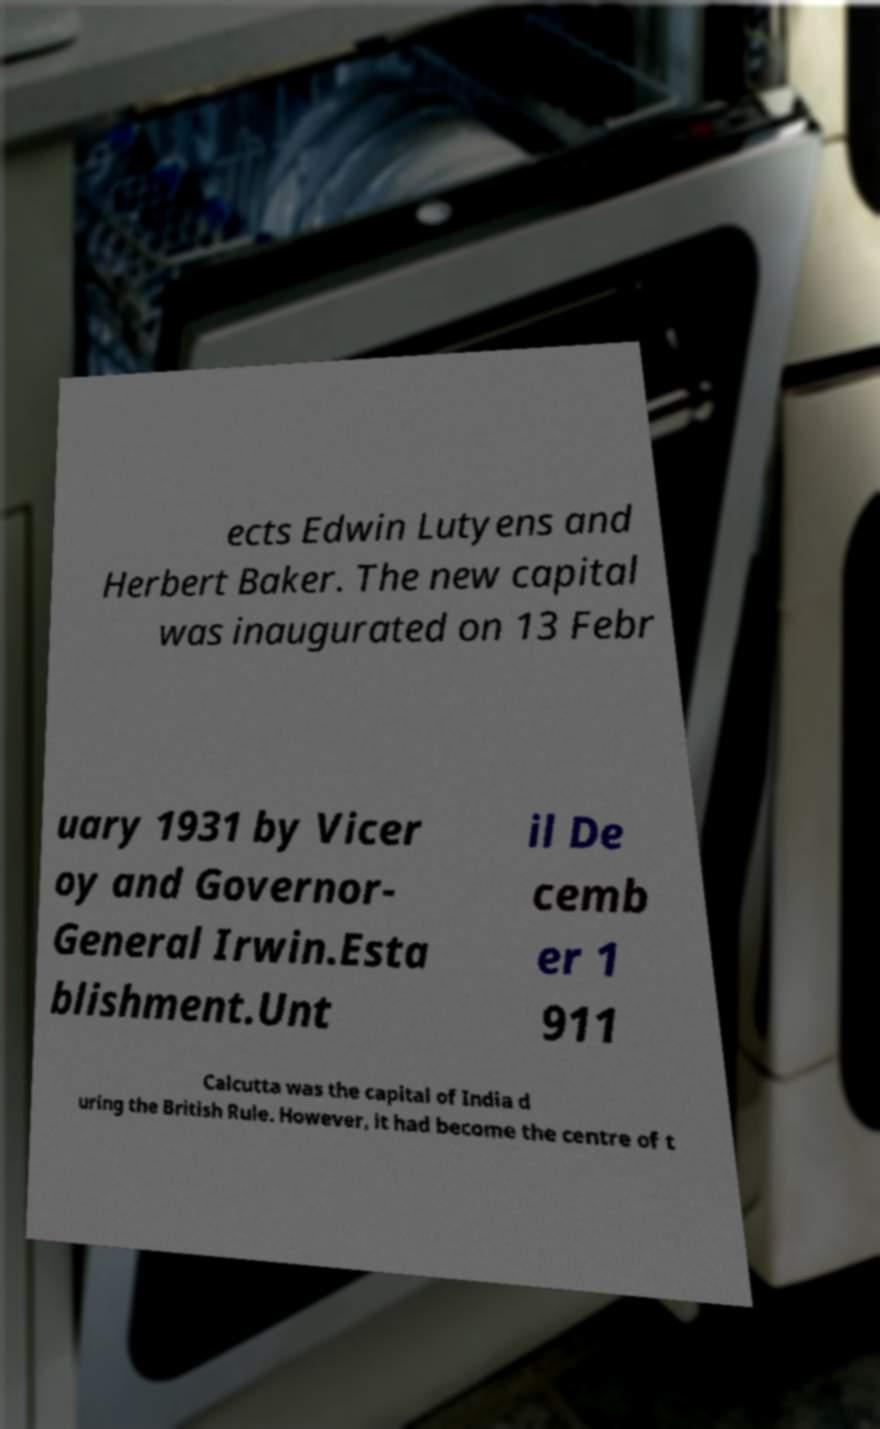Could you assist in decoding the text presented in this image and type it out clearly? ects Edwin Lutyens and Herbert Baker. The new capital was inaugurated on 13 Febr uary 1931 by Vicer oy and Governor- General Irwin.Esta blishment.Unt il De cemb er 1 911 Calcutta was the capital of India d uring the British Rule. However, it had become the centre of t 